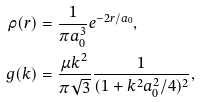Convert formula to latex. <formula><loc_0><loc_0><loc_500><loc_500>\rho ( r ) & = \frac { 1 } { \pi a _ { 0 } ^ { 3 } } e ^ { - 2 r / a _ { 0 } } , \\ g ( k ) & = \frac { \mu k ^ { 2 } } { \pi \sqrt { 3 } } \frac { 1 } { ( 1 + k ^ { 2 } a _ { 0 } ^ { 2 } / 4 ) ^ { 2 } } ,</formula> 